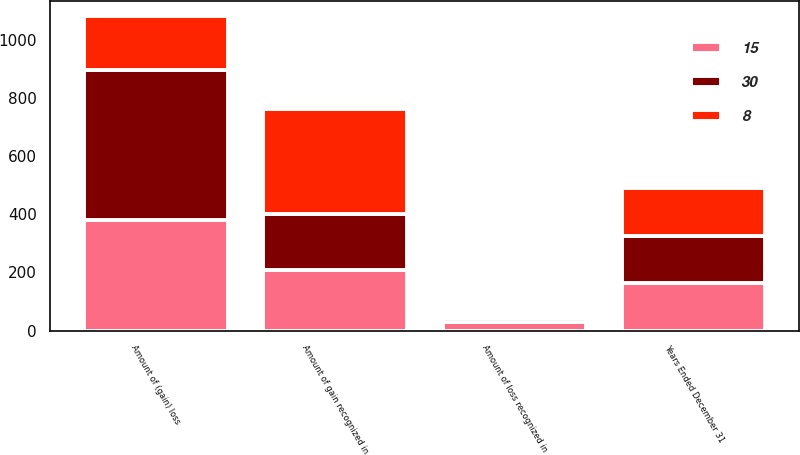Convert chart. <chart><loc_0><loc_0><loc_500><loc_500><stacked_bar_chart><ecel><fcel>Years Ended December 31<fcel>Amount of (gain) loss<fcel>Amount of gain recognized in<fcel>Amount of loss recognized in<nl><fcel>30<fcel>163<fcel>516<fcel>192<fcel>15<nl><fcel>8<fcel>163<fcel>183<fcel>363<fcel>8<nl><fcel>15<fcel>163<fcel>382<fcel>208<fcel>30<nl></chart> 